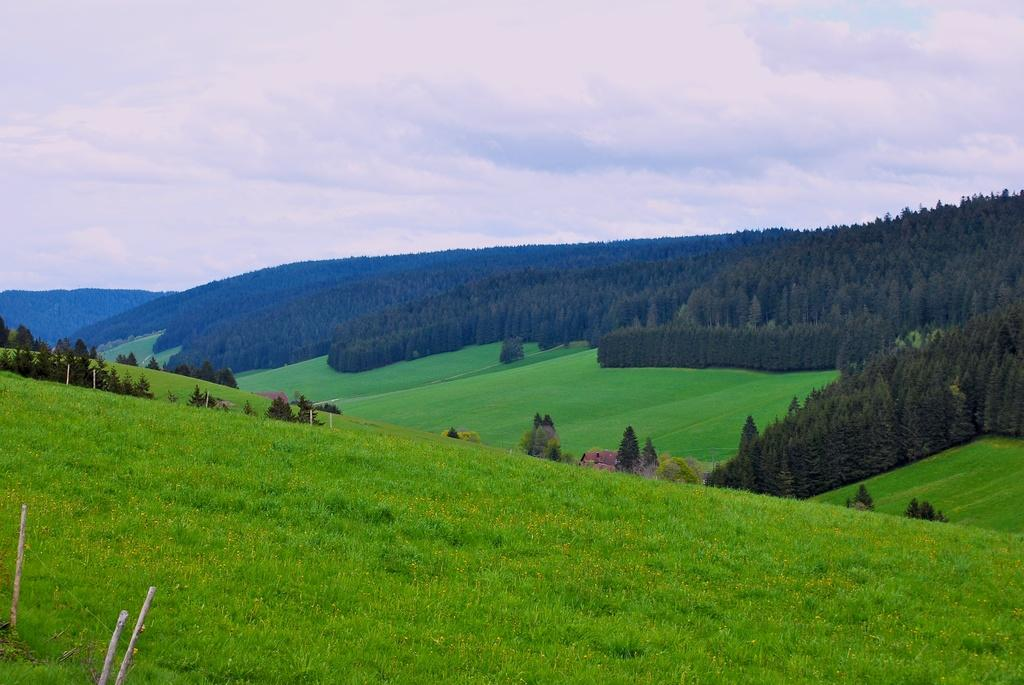What type of terrain is at the bottom of the image? There is a grassy land at the bottom of the image. What can be seen in the middle of the image? There are trees in the middle of the image. What is visible in the background of the image? The sky is visible in the background of the image. What type of coat is hanging from the tree in the image? There is no coat present in the image; it features grassy land, trees, and the sky. How much fuel is needed to power the tail in the image? There is no reference to fuel or a tail in the image. 